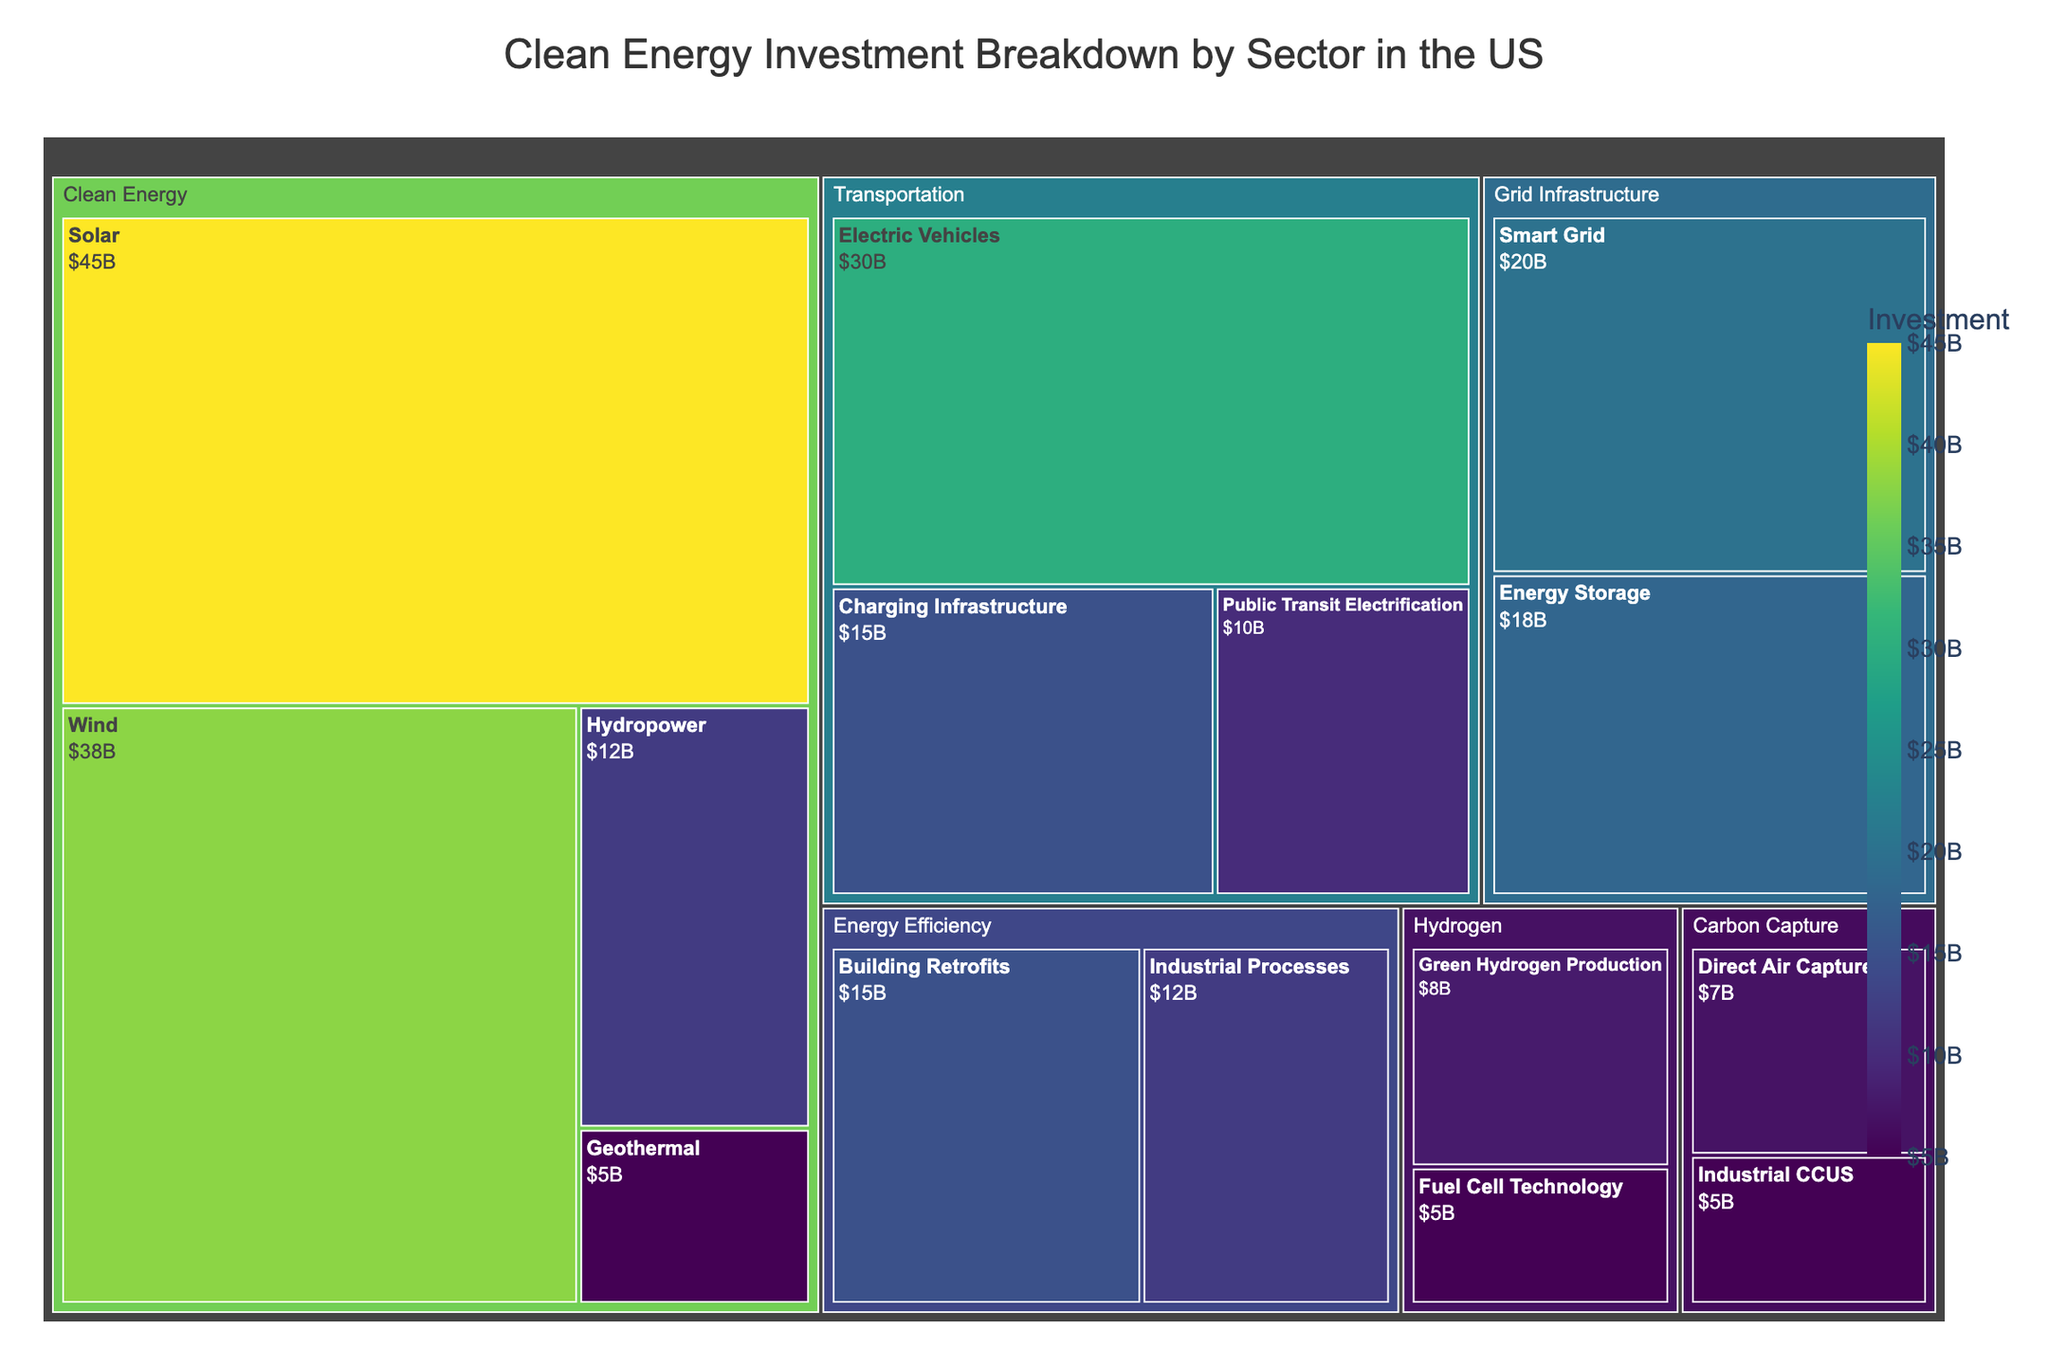What is the title of the treemap? The title is centered at the top of the treemap and provides an overview of what the figure represents.
Answer: Clean Energy Investment Breakdown by Sector in the US Which subsector has the highest investment in Clean Energy? Look at the subsectors under Clean Energy and identify the one with the largest rectangle and highest value.
Answer: Solar What is the total investment in the Transportation sector? Sum the investment values of all subsectors under Transportation (Electric Vehicles, Charging Infrastructure, and Public Transit Electrification): 30 + 15 + 10.
Answer: 55 How does the investment in Smart Grid compare to Energy Storage? Identify the investment values for both subsectors in Grid Infrastructure and compare: Smart Grid (20) and Energy Storage (18).
Answer: Smart Grid has a higher investment Which sector has the smallest total investment, and what is its value? Compare the total investments of all sectors by summing the investments of their respective subsectors: Clean Energy (100), Transportation (55), Grid Infrastructure (38), Energy Efficiency (27), Hydrogen (13), Carbon Capture (12). Identify the smallest.
Answer: Carbon Capture, 12 What is the combined investment in Solar and Wind? Add the investment values of the Solar and Wind subsectors: 45 (Solar) + 38 (Wind).
Answer: 83 Is the investment in Electric Vehicles greater than the investment in Building Retrofits? Compare the investment values for Electric Vehicles (30) and Building Retrofits (15).
Answer: Yes Which sector has more investment: Energy Efficiency or Hydrogen? Compare the total investments in Energy Efficiency (15 + 12) and Hydrogen (8 + 5).
Answer: Energy Efficiency What is the difference between the highest and lowest investments in any subsector? Identify the highest (Solar, 45) and lowest (Fuel Cell Technology, 5) subsector investments and calculate the difference: 45 - 5.
Answer: 40 What's the average investment across all subsectors? Sum all the investment values and divide by the number of subsectors: (45 + 38 + 12 + 5 + 30 + 15 + 10 + 20 + 18 + 15 + 12 + 8 + 5 + 7 + 5) / 15.
Answer: 16.67 